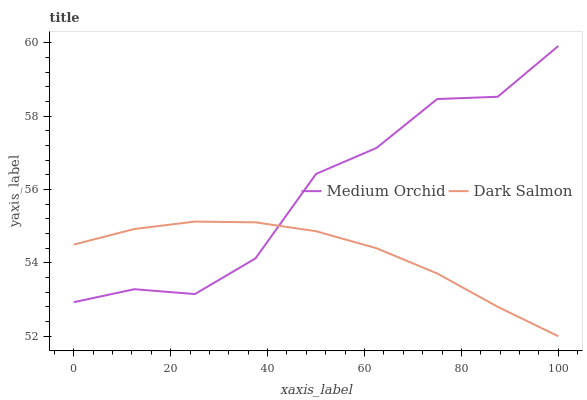Does Dark Salmon have the minimum area under the curve?
Answer yes or no. Yes. Does Medium Orchid have the maximum area under the curve?
Answer yes or no. Yes. Does Dark Salmon have the maximum area under the curve?
Answer yes or no. No. Is Dark Salmon the smoothest?
Answer yes or no. Yes. Is Medium Orchid the roughest?
Answer yes or no. Yes. Is Dark Salmon the roughest?
Answer yes or no. No. Does Dark Salmon have the lowest value?
Answer yes or no. Yes. Does Medium Orchid have the highest value?
Answer yes or no. Yes. Does Dark Salmon have the highest value?
Answer yes or no. No. Does Medium Orchid intersect Dark Salmon?
Answer yes or no. Yes. Is Medium Orchid less than Dark Salmon?
Answer yes or no. No. Is Medium Orchid greater than Dark Salmon?
Answer yes or no. No. 